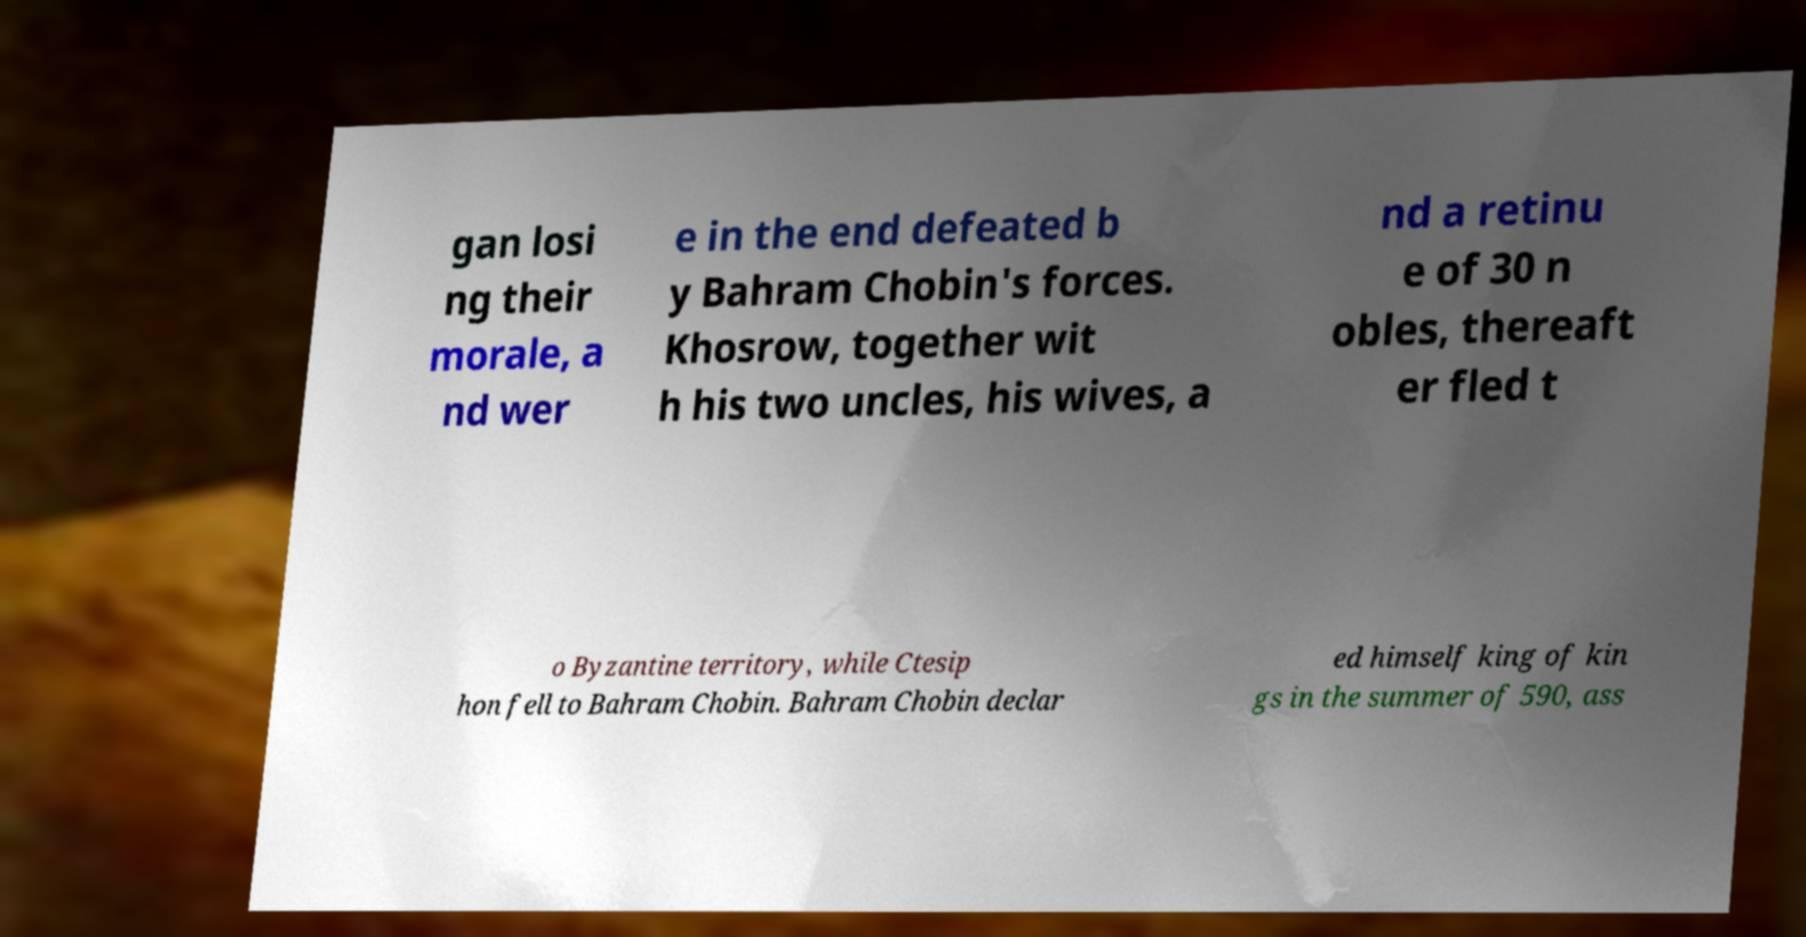Please identify and transcribe the text found in this image. gan losi ng their morale, a nd wer e in the end defeated b y Bahram Chobin's forces. Khosrow, together wit h his two uncles, his wives, a nd a retinu e of 30 n obles, thereaft er fled t o Byzantine territory, while Ctesip hon fell to Bahram Chobin. Bahram Chobin declar ed himself king of kin gs in the summer of 590, ass 